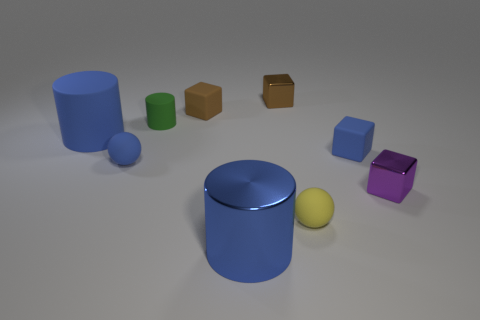Subtract 1 blocks. How many blocks are left? 3 Subtract all blue blocks. How many blocks are left? 3 Subtract all gray blocks. Subtract all yellow balls. How many blocks are left? 4 Add 1 brown rubber things. How many objects exist? 10 Subtract all blocks. How many objects are left? 5 Add 9 large blue rubber objects. How many large blue rubber objects exist? 10 Subtract 1 blue spheres. How many objects are left? 8 Subtract all small brown cubes. Subtract all small cyan things. How many objects are left? 7 Add 8 tiny brown matte blocks. How many tiny brown matte blocks are left? 9 